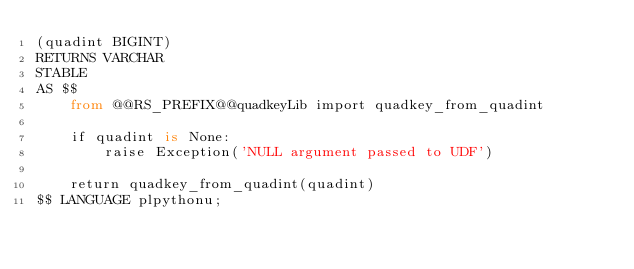Convert code to text. <code><loc_0><loc_0><loc_500><loc_500><_SQL_>(quadint BIGINT)
RETURNS VARCHAR
STABLE
AS $$
    from @@RS_PREFIX@@quadkeyLib import quadkey_from_quadint
    
    if quadint is None:
        raise Exception('NULL argument passed to UDF')
    
    return quadkey_from_quadint(quadint)
$$ LANGUAGE plpythonu;</code> 